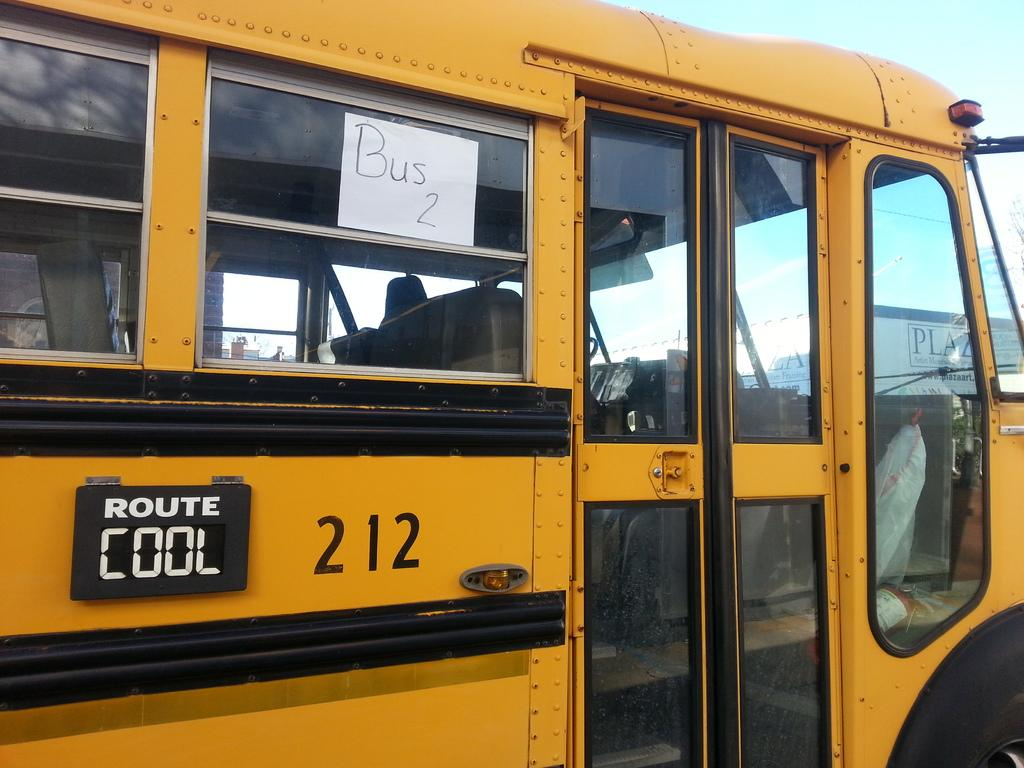<image>
Describe the image concisely. A yellow school bus that has the words route cool 212 on it. 